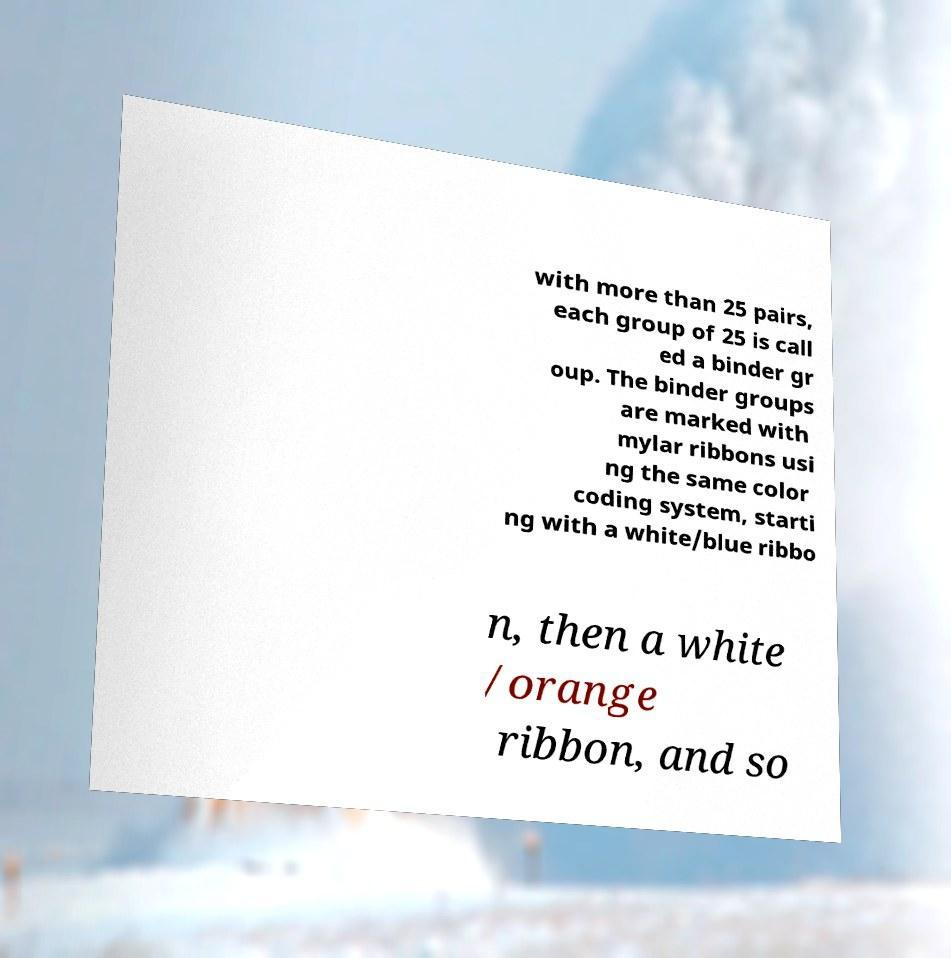Can you read and provide the text displayed in the image?This photo seems to have some interesting text. Can you extract and type it out for me? with more than 25 pairs, each group of 25 is call ed a binder gr oup. The binder groups are marked with mylar ribbons usi ng the same color coding system, starti ng with a white/blue ribbo n, then a white /orange ribbon, and so 